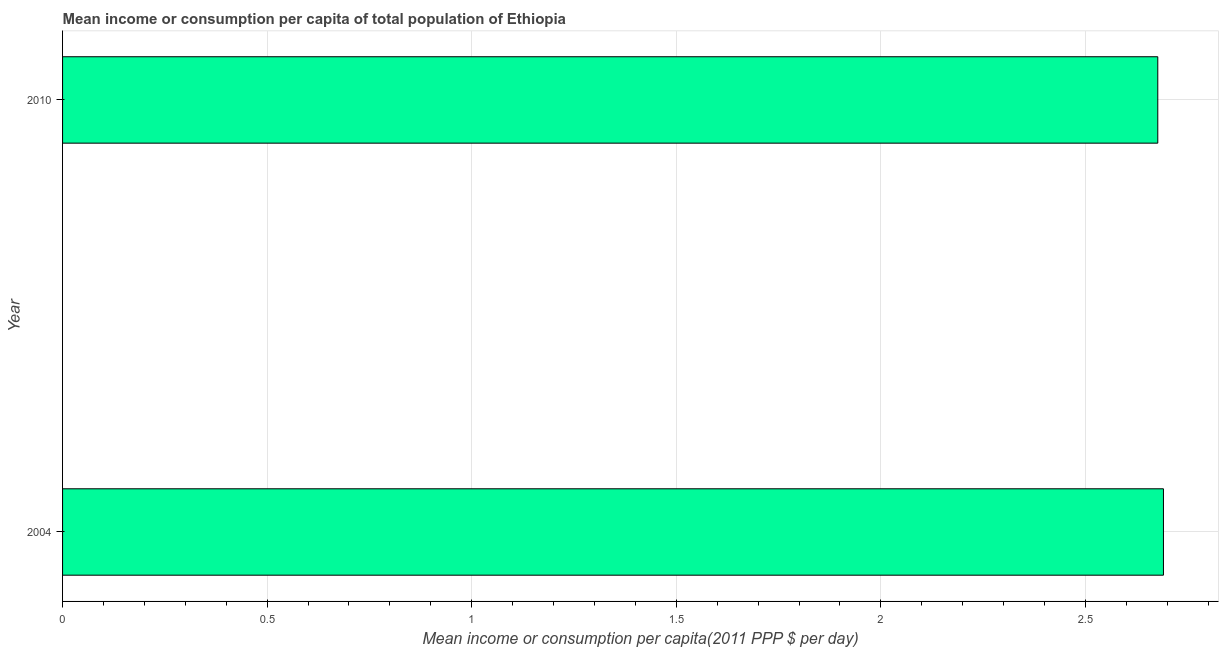What is the title of the graph?
Give a very brief answer. Mean income or consumption per capita of total population of Ethiopia. What is the label or title of the X-axis?
Give a very brief answer. Mean income or consumption per capita(2011 PPP $ per day). What is the mean income or consumption in 2004?
Give a very brief answer. 2.69. Across all years, what is the maximum mean income or consumption?
Give a very brief answer. 2.69. Across all years, what is the minimum mean income or consumption?
Your answer should be very brief. 2.68. In which year was the mean income or consumption maximum?
Make the answer very short. 2004. In which year was the mean income or consumption minimum?
Your answer should be compact. 2010. What is the sum of the mean income or consumption?
Ensure brevity in your answer.  5.37. What is the difference between the mean income or consumption in 2004 and 2010?
Offer a terse response. 0.01. What is the average mean income or consumption per year?
Your answer should be compact. 2.68. What is the median mean income or consumption?
Your answer should be very brief. 2.68. In how many years, is the mean income or consumption greater than 0.7 $?
Make the answer very short. 2. Do a majority of the years between 2010 and 2004 (inclusive) have mean income or consumption greater than 1.4 $?
Offer a terse response. No. Is the mean income or consumption in 2004 less than that in 2010?
Ensure brevity in your answer.  No. Are all the bars in the graph horizontal?
Your response must be concise. Yes. Are the values on the major ticks of X-axis written in scientific E-notation?
Make the answer very short. No. What is the Mean income or consumption per capita(2011 PPP $ per day) in 2004?
Provide a succinct answer. 2.69. What is the Mean income or consumption per capita(2011 PPP $ per day) in 2010?
Provide a succinct answer. 2.68. What is the difference between the Mean income or consumption per capita(2011 PPP $ per day) in 2004 and 2010?
Ensure brevity in your answer.  0.01. What is the ratio of the Mean income or consumption per capita(2011 PPP $ per day) in 2004 to that in 2010?
Make the answer very short. 1. 